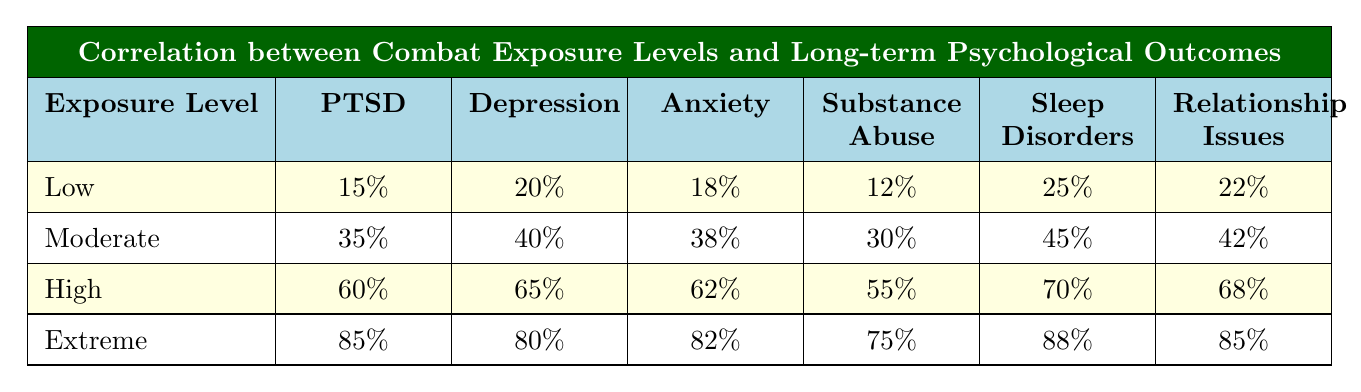What percentage of individuals with low combat exposure experience PTSD? According to the table, individuals with low combat exposure have a PTSD rate of 15%.
Answer: 15% What is the percentage difference in depression rates between moderate and extreme combat exposure? For moderate exposure, the depression rate is 40%, and for extreme exposure, it is 80%. The difference is 80% - 40% = 40%.
Answer: 40% Which psychological outcome has the highest percentage for individuals with high combat exposure? In the table, the highest percentage for high exposure is for sleep disorders, which is 70%.
Answer: 70% Is the percentage of substance abuse higher for extreme exposure than for high exposure? The substance abuse percentage for extreme exposure is 75%, while for high exposure, it is 55%. Since 75% > 55%, the statement is true.
Answer: Yes What is the average percentage of relationship issues for all exposure levels combined? Adding the percentages for relationship issues: 22% (low) + 42% (moderate) + 68% (high) + 85% (extreme) = 217%, then dividing by 4 gives an average of 217% / 4 = 54.25%.
Answer: 54.25% How does the PTSD rate for individuals with extreme exposure compare to those with low exposure? The PTSD rate for extreme exposure is 85%, while low exposure is 15%. Therefore, extreme exposure has a significantly higher rate at a difference of 85% - 15% = 70%.
Answer: 70% higher If one were to categorize the relationship issues percentages into five categories (low, moderate, high, extreme, very high), where would the relationship issues for high exposure fit? Relationship issues for high exposure are at 68%. Comparing this to the defined categories, 68% would be classified as high due to proximity to the values in the table.
Answer: High What is the lowest percentage for anxiety across all exposure levels? The lowest percentage for anxiety in the table is 18%, which corresponds to low exposure.
Answer: 18% 